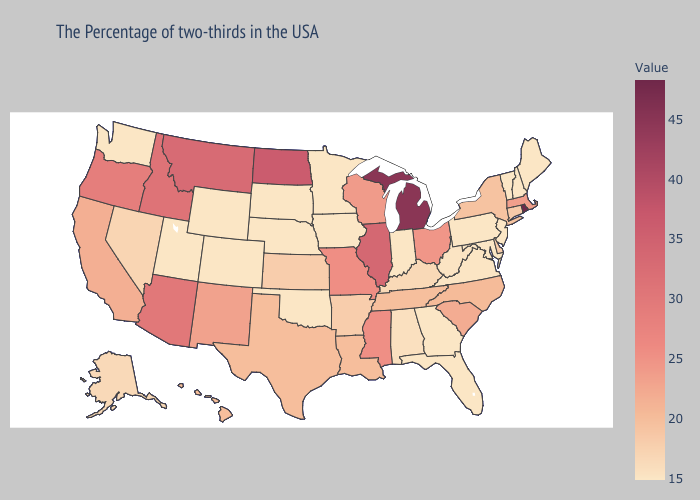Which states have the highest value in the USA?
Be succinct. Rhode Island. Which states have the lowest value in the USA?
Be succinct. Maine, New Hampshire, Vermont, New Jersey, Maryland, Pennsylvania, Florida, Georgia, Indiana, Minnesota, Iowa, Nebraska, Oklahoma, South Dakota, Wyoming, Colorado, Utah, Washington. Among the states that border Illinois , does Missouri have the lowest value?
Write a very short answer. No. Does Alaska have the lowest value in the USA?
Write a very short answer. No. Does Arkansas have the highest value in the USA?
Short answer required. No. Is the legend a continuous bar?
Keep it brief. Yes. Which states have the lowest value in the USA?
Answer briefly. Maine, New Hampshire, Vermont, New Jersey, Maryland, Pennsylvania, Florida, Georgia, Indiana, Minnesota, Iowa, Nebraska, Oklahoma, South Dakota, Wyoming, Colorado, Utah, Washington. 